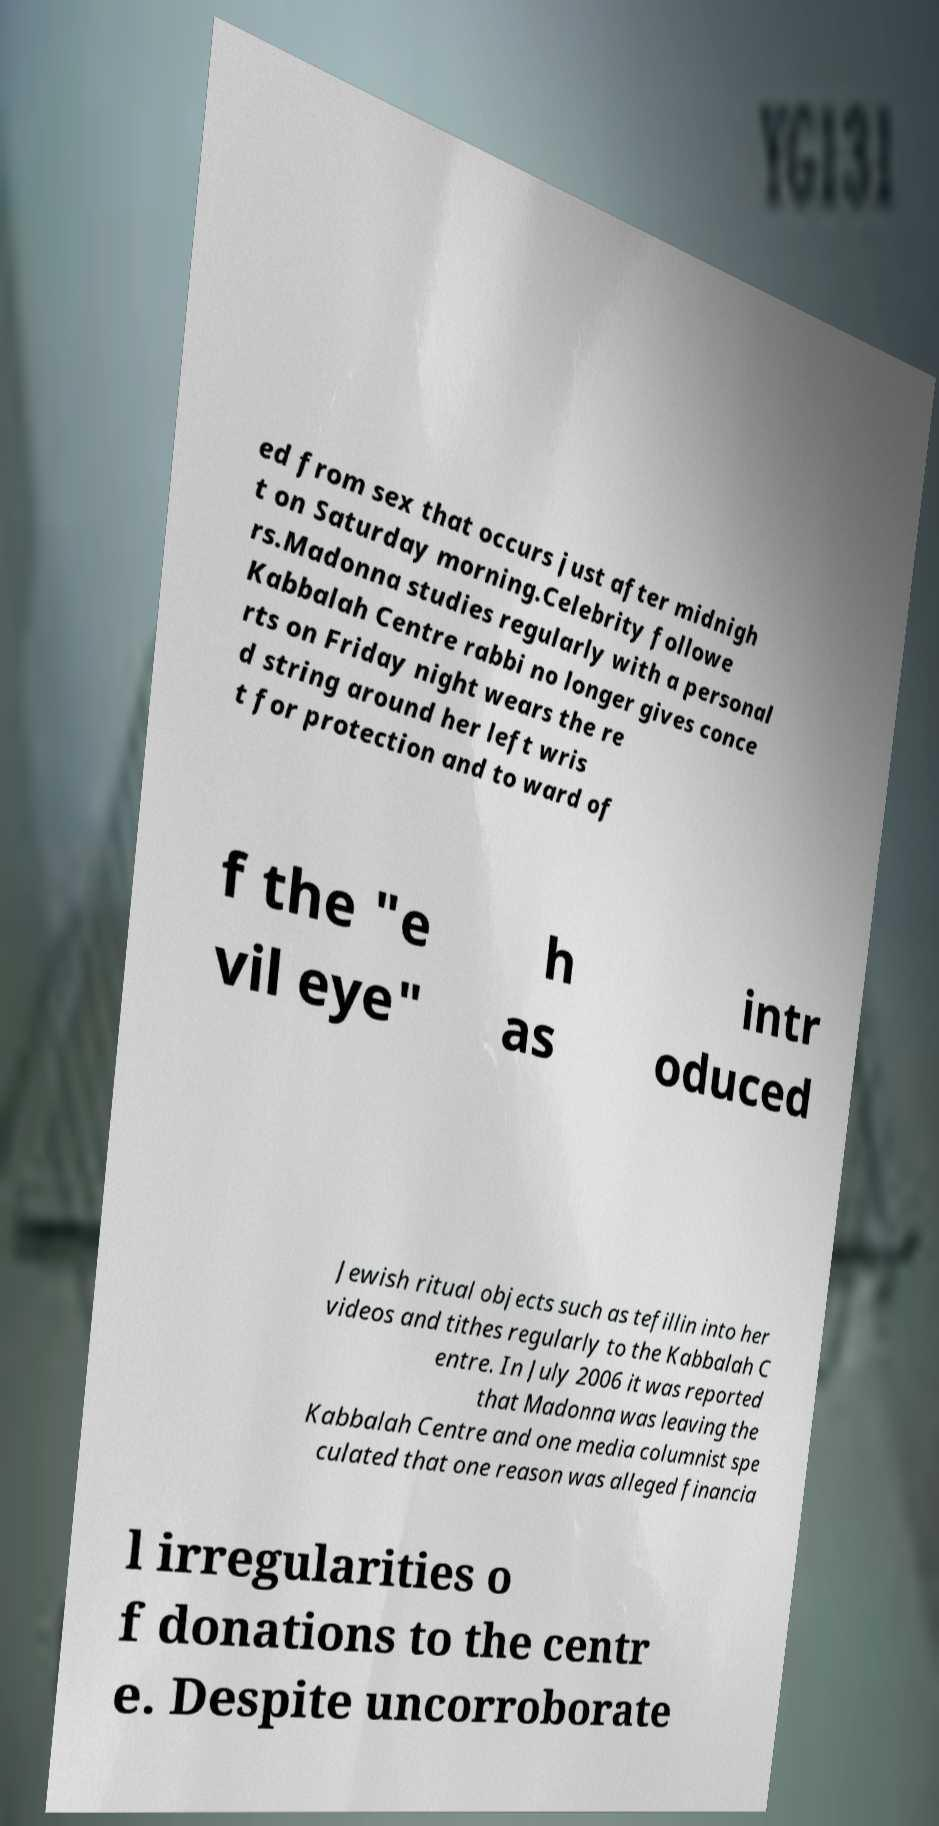I need the written content from this picture converted into text. Can you do that? ed from sex that occurs just after midnigh t on Saturday morning.Celebrity followe rs.Madonna studies regularly with a personal Kabbalah Centre rabbi no longer gives conce rts on Friday night wears the re d string around her left wris t for protection and to ward of f the "e vil eye" h as intr oduced Jewish ritual objects such as tefillin into her videos and tithes regularly to the Kabbalah C entre. In July 2006 it was reported that Madonna was leaving the Kabbalah Centre and one media columnist spe culated that one reason was alleged financia l irregularities o f donations to the centr e. Despite uncorroborate 